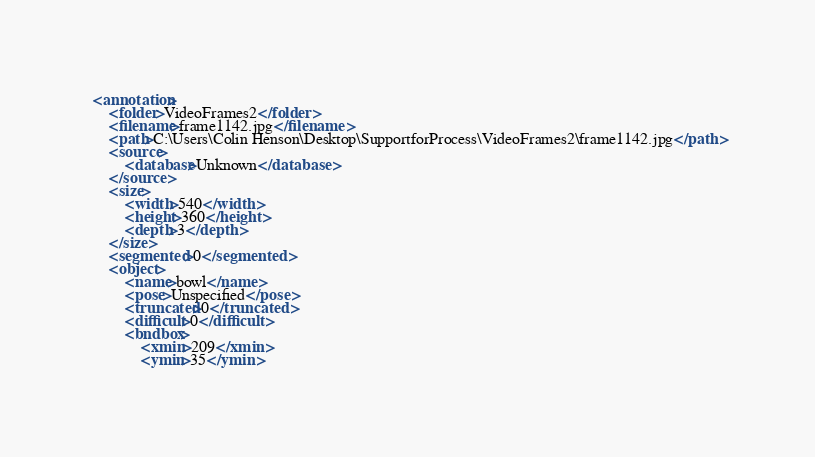Convert code to text. <code><loc_0><loc_0><loc_500><loc_500><_XML_><annotation>
	<folder>VideoFrames2</folder>
	<filename>frame1142.jpg</filename>
	<path>C:\Users\Colin Henson\Desktop\SupportforProcess\VideoFrames2\frame1142.jpg</path>
	<source>
		<database>Unknown</database>
	</source>
	<size>
		<width>540</width>
		<height>360</height>
		<depth>3</depth>
	</size>
	<segmented>0</segmented>
	<object>
		<name>bowl</name>
		<pose>Unspecified</pose>
		<truncated>0</truncated>
		<difficult>0</difficult>
		<bndbox>
			<xmin>209</xmin>
			<ymin>35</ymin></code> 